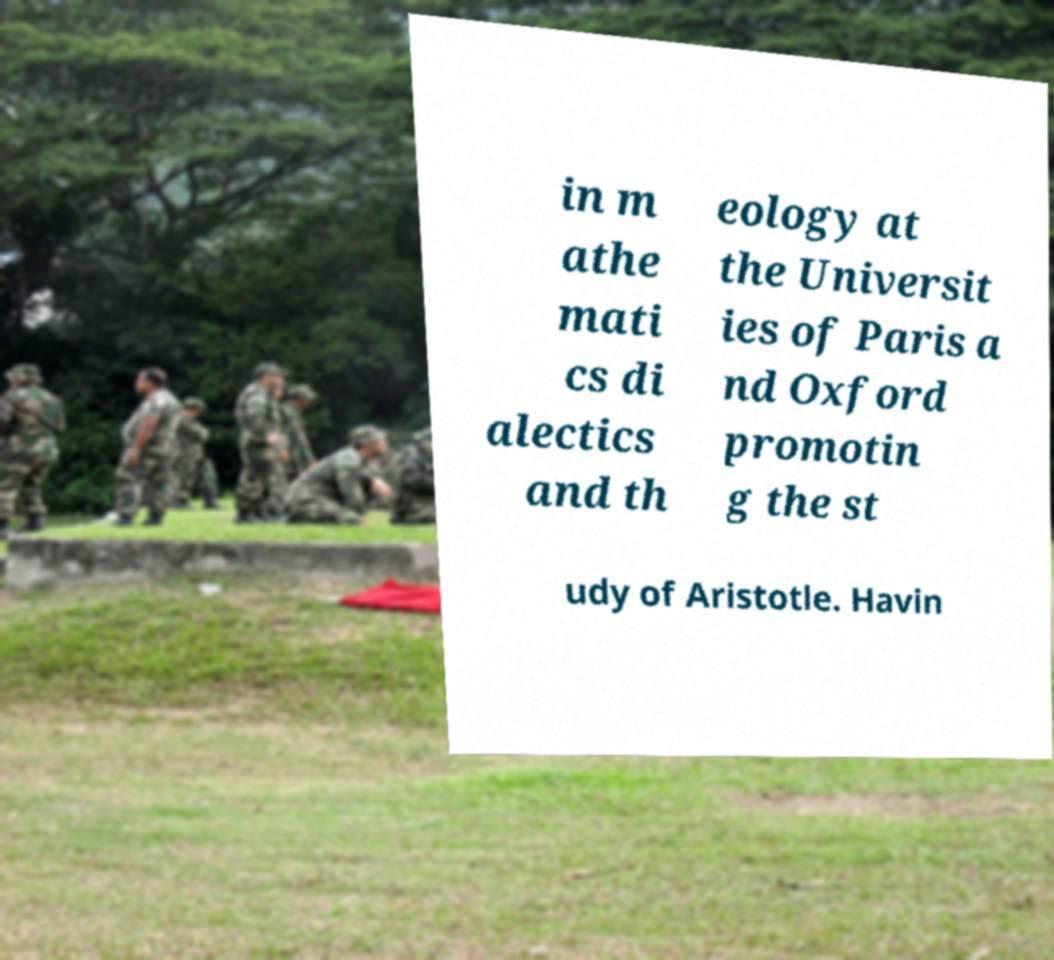Can you accurately transcribe the text from the provided image for me? in m athe mati cs di alectics and th eology at the Universit ies of Paris a nd Oxford promotin g the st udy of Aristotle. Havin 